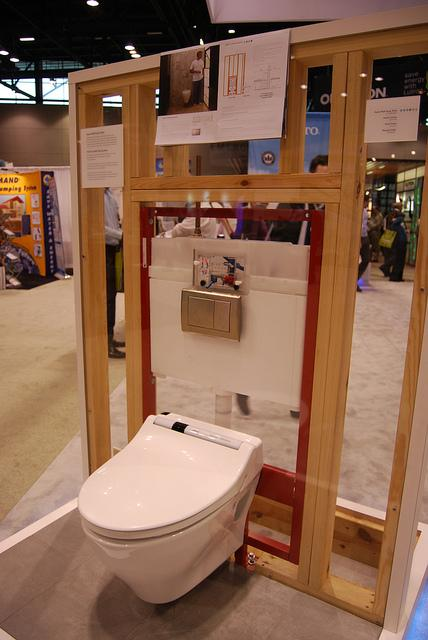Where is this toilet located?

Choices:
A) car
B) bathroom
C) kitchen
D) expo expo 